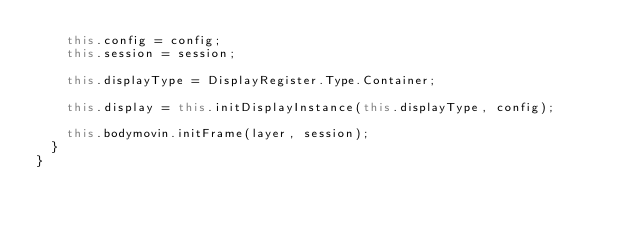Convert code to text. <code><loc_0><loc_0><loc_500><loc_500><_JavaScript_>    this.config = config;
    this.session = session;

    this.displayType = DisplayRegister.Type.Container;

    this.display = this.initDisplayInstance(this.displayType, config);

    this.bodymovin.initFrame(layer, session);
  }
}
</code> 